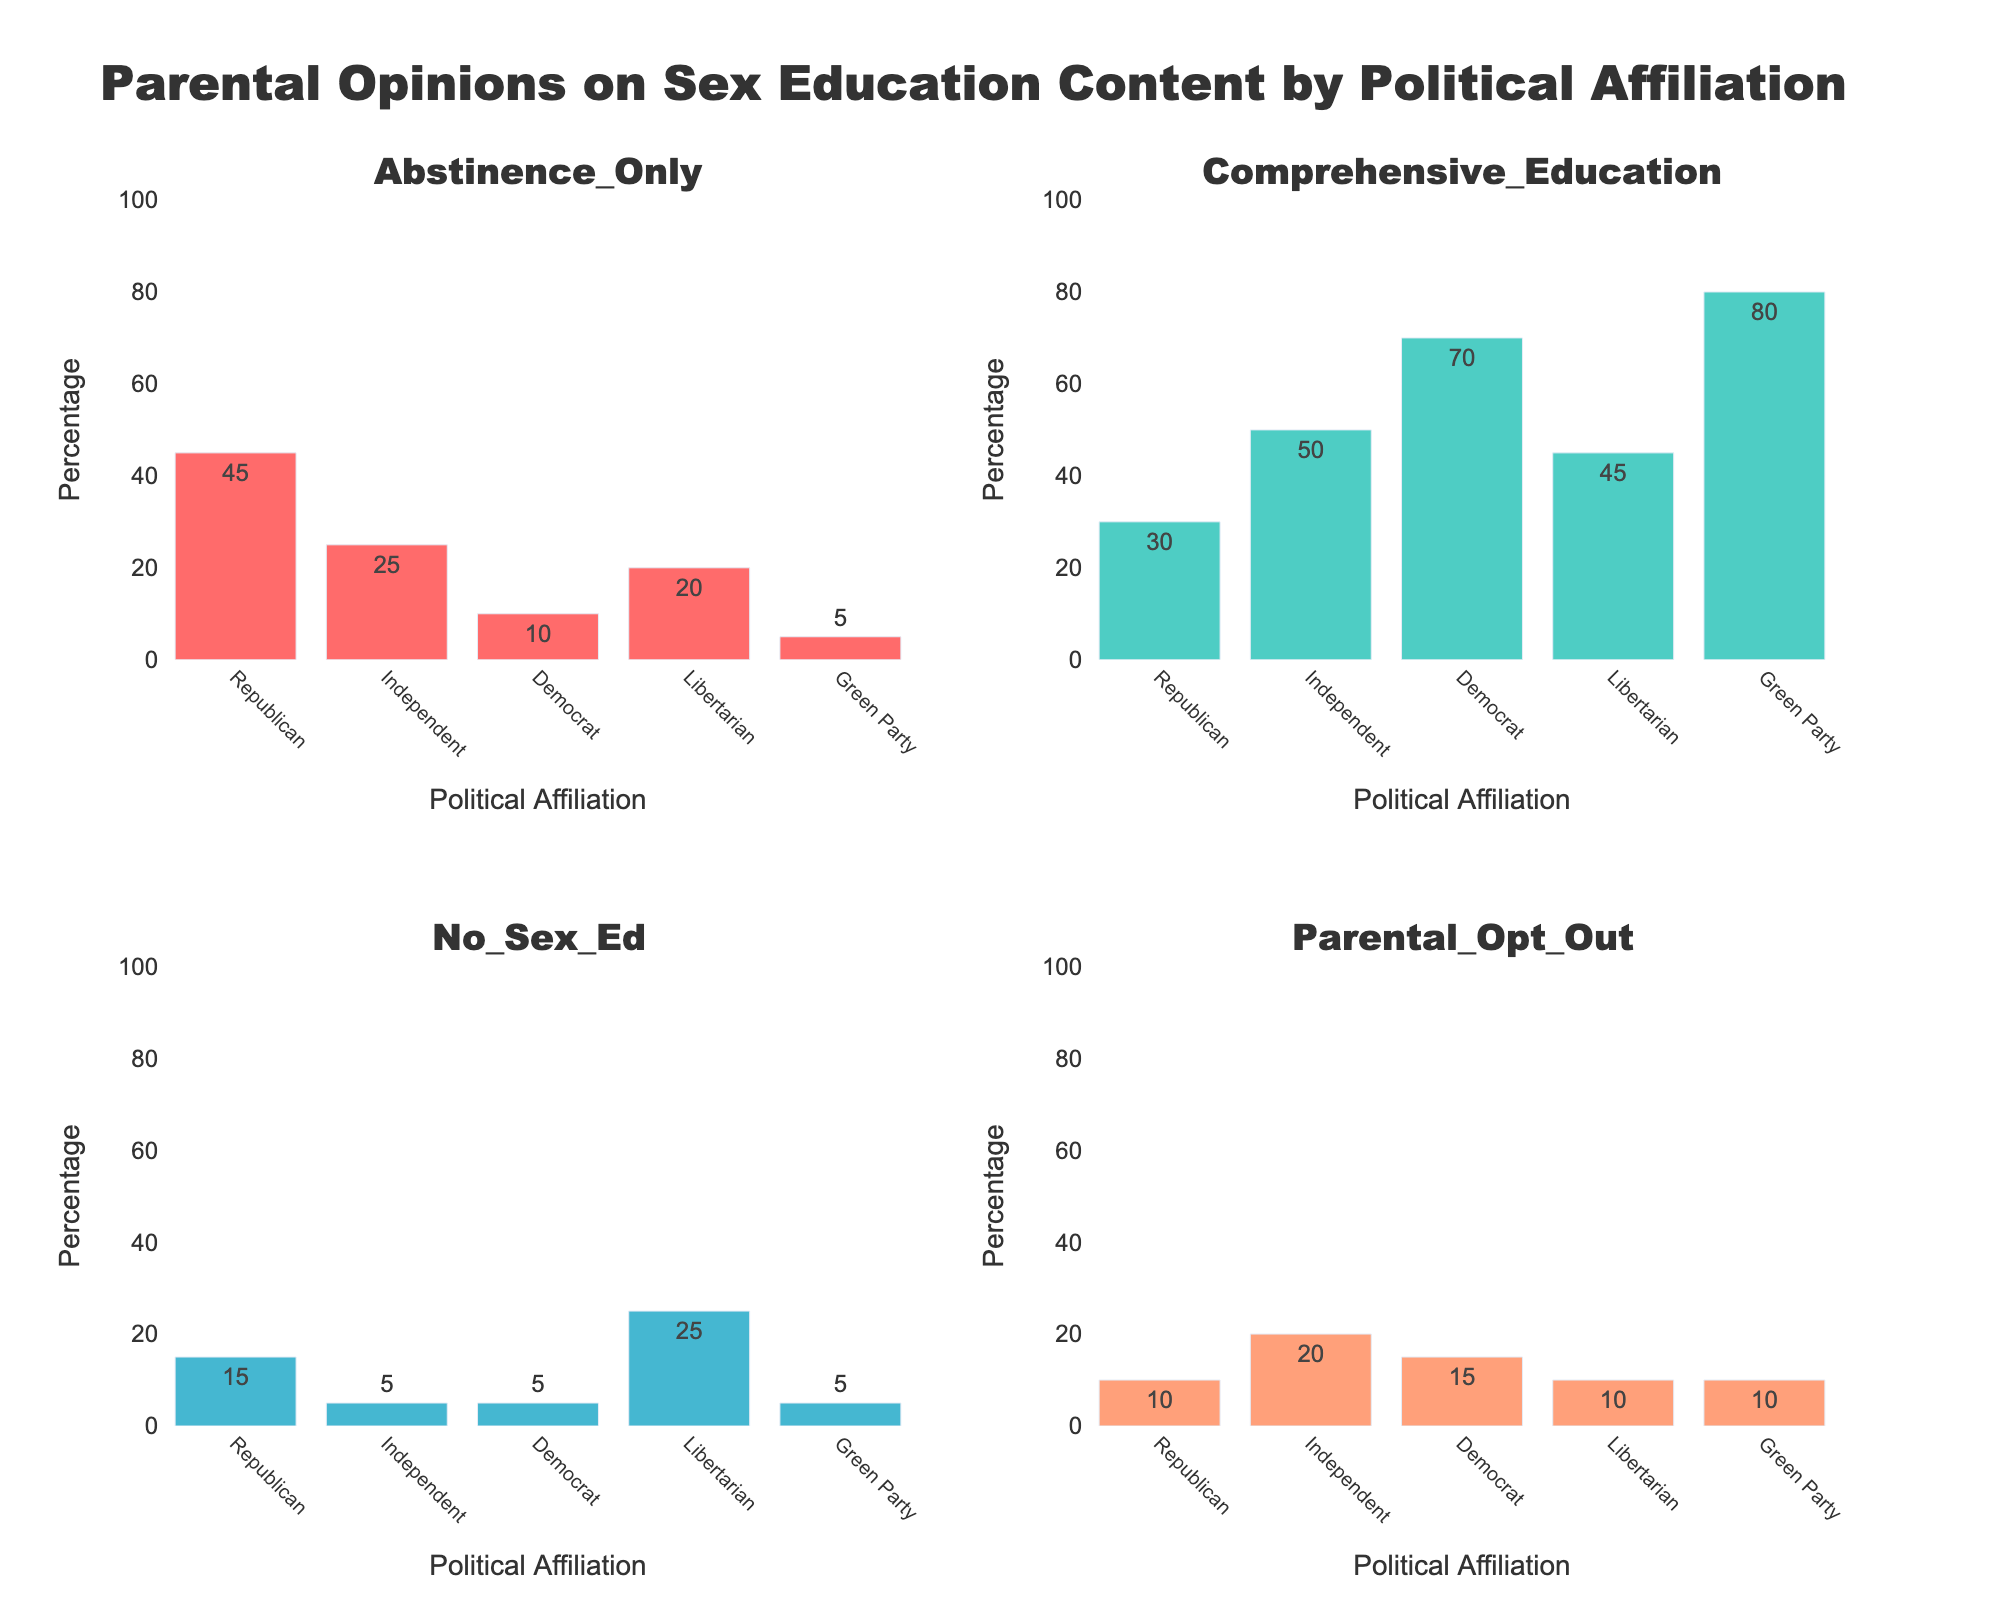What is the title of the main figure? The title of the main figure is displayed at the top. It reads "Faculty Composition Analysis" in large, bold font.
Answer: Faculty Composition Analysis Which area of specialization has the highest number of faculty members? The pie chart in the top-left subplot, labeled "Faculty Distribution by Area," shows that "Information Science" has the largest slice.
Answer: Information Science How many total Associate Professors are there across all areas? The bar chart in the top-right subplot, labeled "Rank Distribution," shows a bar labeled "Associate Professor." The height corresponds to 30 faculty members.
Answer: 30 What is the lightest color used in the heatmap? The heatmap's color scale ranges from light yellow to dark red. The lightest color visible is light yellow, representing the lowest counts.
Answer: Light yellow How many more Professors are there in Human-Computer Interaction compared to Digital Archives? The bar chart in the bottom-left subplot displays counts for each area and rank. Human-Computer Interaction has 9 Professors, while Digital Archives has 5. The difference is 9 - 5.
Answer: 4 What proportion of faculty are Associate Professors in Information Policy? In the pie chart, "Information Policy" is shown, and its slice is divided between ranks. The Associate Professor segment is 5 out of 15 total for Information Policy. The proportion is 5/15.
Answer: 1/3 Which area ranks are more evenly distributed: Information Science or Data Science? Comparing the stacked bars in the bottom-left subplot for "Information Science" and "Data Science," it is clear that "Data Science" has a more even distribution across Professors (10), Associate Professors (6), and Assistant Professors (8).
Answer: Data Science Are there more Professors or Assistant Professors in total? The bar chart in the top-right subplot shows the total count. Professors have a higher bar than Assistant Professors. Quick visual inspection confirms there are more Professors.
Answer: Professors What is the total number of faculty members in Digital Archives? In the bottom-left stacked bar chart by area, Digital Archives has counts of 5 (Professor), 4 (Associate), and 3 (Assistant). Total is 5 + 4 + 3.
Answer: 12 Which rank has the least representation in Digital Archives? Looking at the bottom-left bar for Digital Archives, the smallest segment is for Assistant Professors, which has 3 members.
Answer: Assistant Professor 